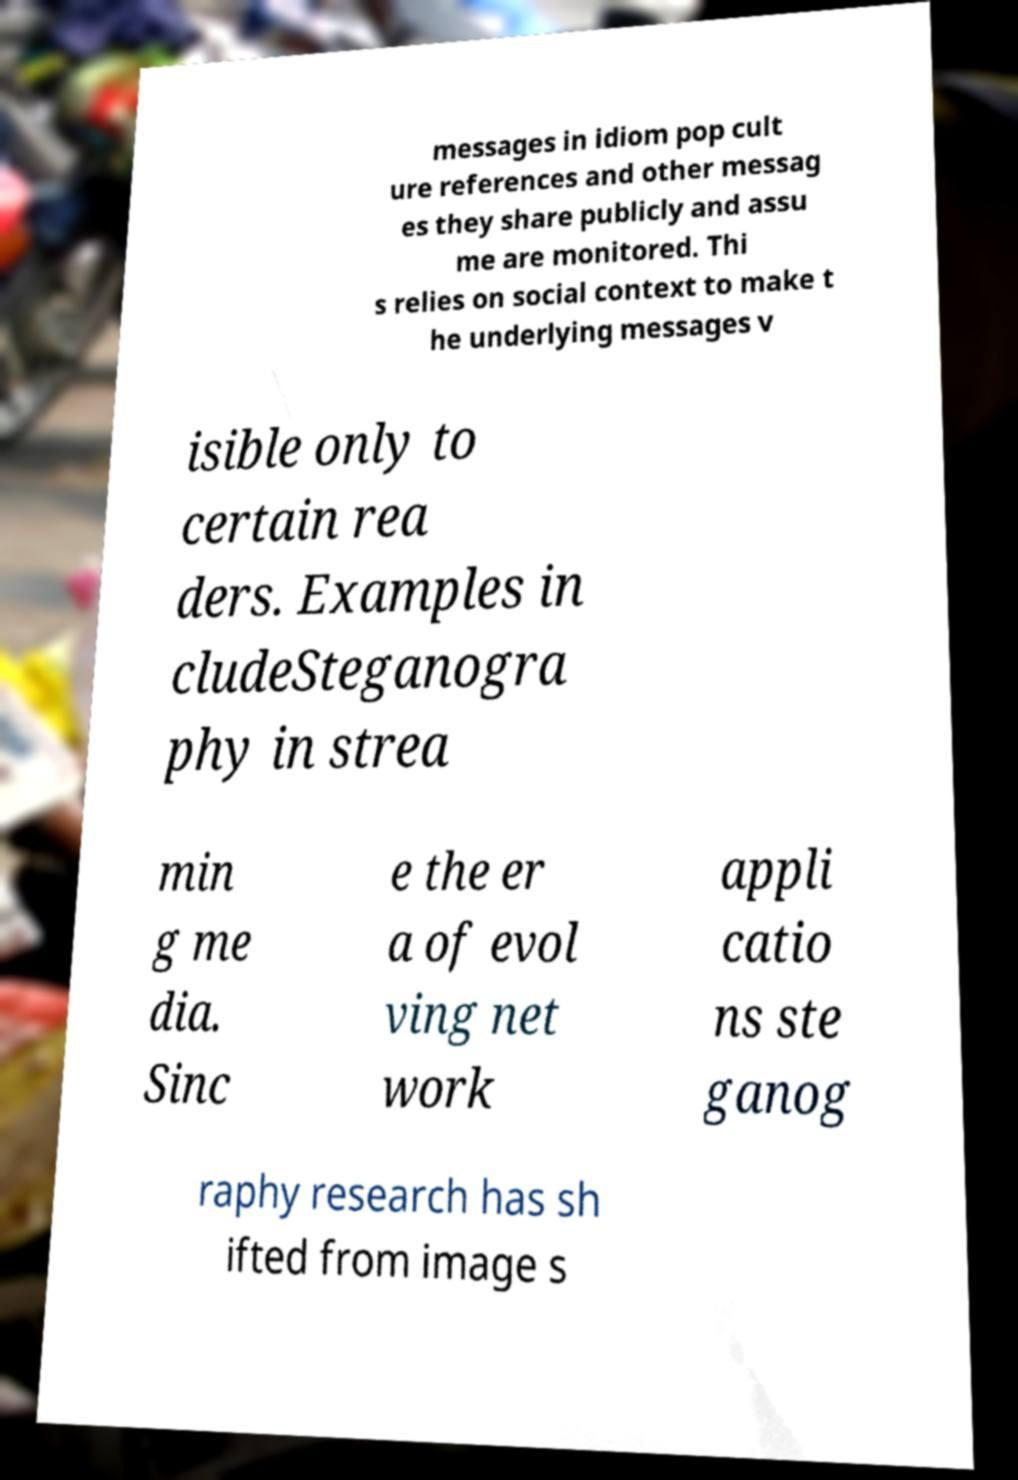Please identify and transcribe the text found in this image. messages in idiom pop cult ure references and other messag es they share publicly and assu me are monitored. Thi s relies on social context to make t he underlying messages v isible only to certain rea ders. Examples in cludeSteganogra phy in strea min g me dia. Sinc e the er a of evol ving net work appli catio ns ste ganog raphy research has sh ifted from image s 